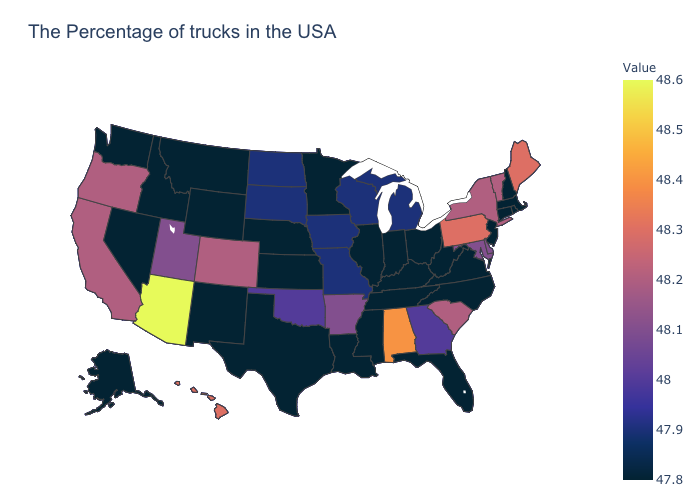Which states have the highest value in the USA?
Short answer required. Arizona. Does the map have missing data?
Short answer required. No. Among the states that border Colorado , which have the lowest value?
Answer briefly. Kansas, Nebraska, Wyoming, New Mexico. 